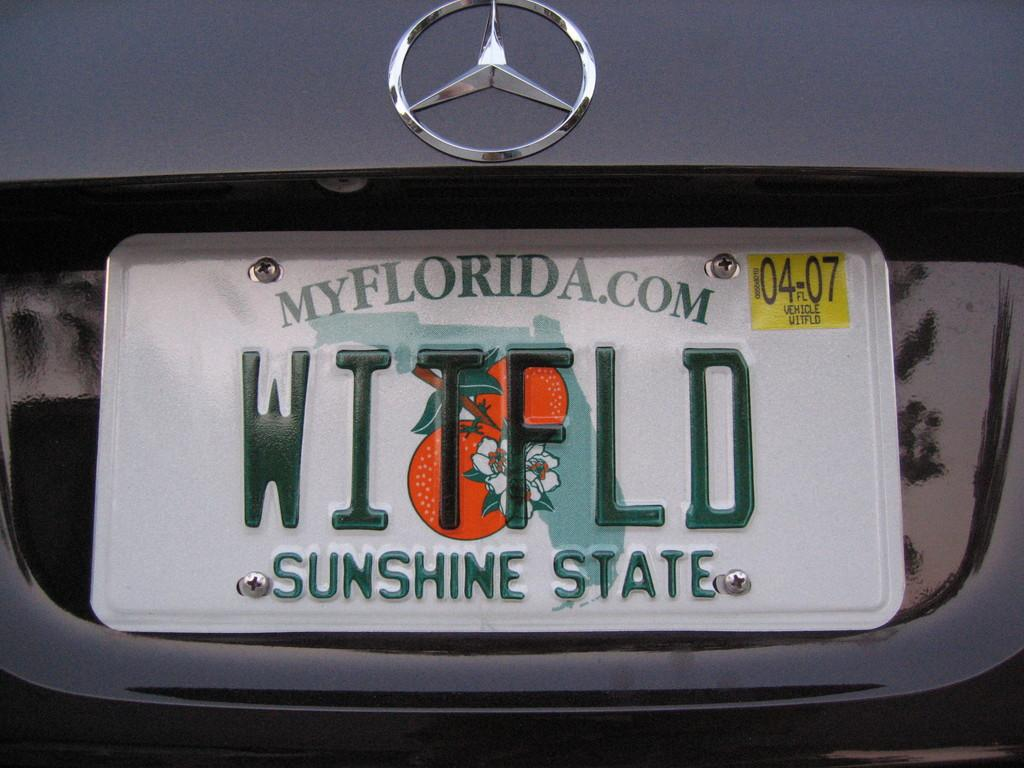<image>
Relay a brief, clear account of the picture shown. The grey Mercedes Benz is from Florida according to its licence plate. 